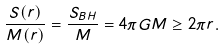<formula> <loc_0><loc_0><loc_500><loc_500>\frac { S ( r ) } { M ( r ) } = \frac { S _ { B H } } { M } = 4 \pi G M \geq 2 \pi r .</formula> 